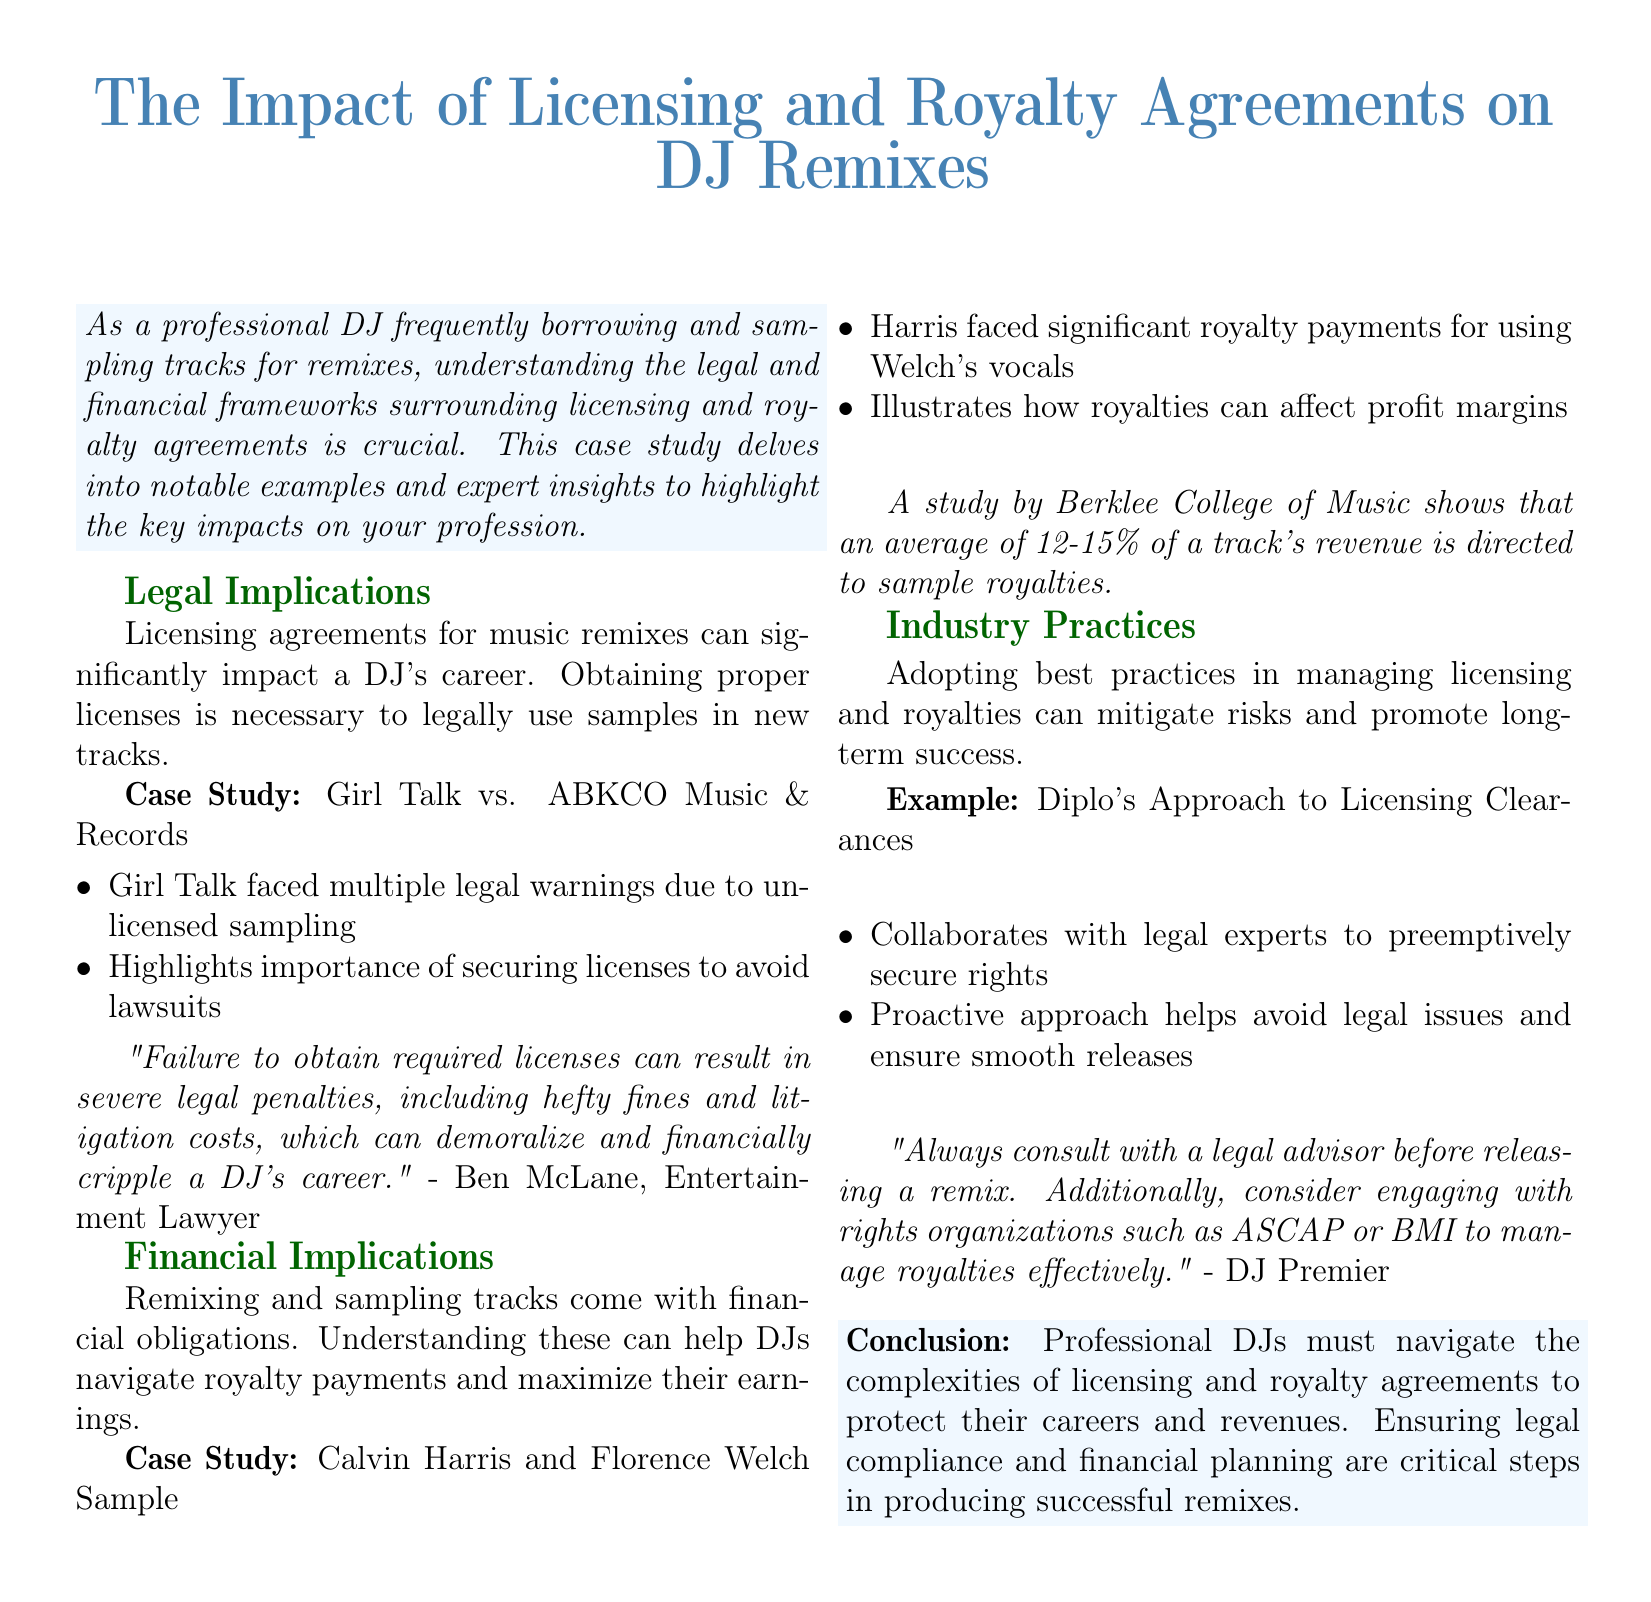what is the title of the case study? The title of the case study is explicitly stated at the beginning of the document.
Answer: The Impact of Licensing and Royalty Agreements on DJ Remixes who faced legal warnings due to unlicensed sampling? The document provides a specific example of a DJ who encountered legal issues related to sampling without a license.
Answer: Girl Talk what percentage of a track's revenue is directed to sample royalties according to the Berklee College of Music? The document cites a study that mentions a specific average percentage of revenue allocated to sample royalties.
Answer: 12-15% which DJ collaborates with legal experts to secure rights? The document includes an example of a DJ known for a proactive approach to licensing clearances.
Answer: Diplo what is a potential consequence of failing to obtain required licenses? The document highlights the serious implications that can arise for DJs who do not secure necessary legal permissions.
Answer: Legal penalties who expressed the importance of consulting a legal advisor before releasing a remix? A quote in the document attributes the advice about legal consultation to a specific DJ.
Answer: DJ Premier what was the financial impact mentioned regarding Calvin Harris and Florence Welch? The document discusses a specific financial obligation associated with using another artist's vocals in remixes.
Answer: Significant royalty payments what is a recommended organization for managing royalties effectively? The document suggests particular organizations that DJs can engage with for royalty management.
Answer: ASCAP or BMI 